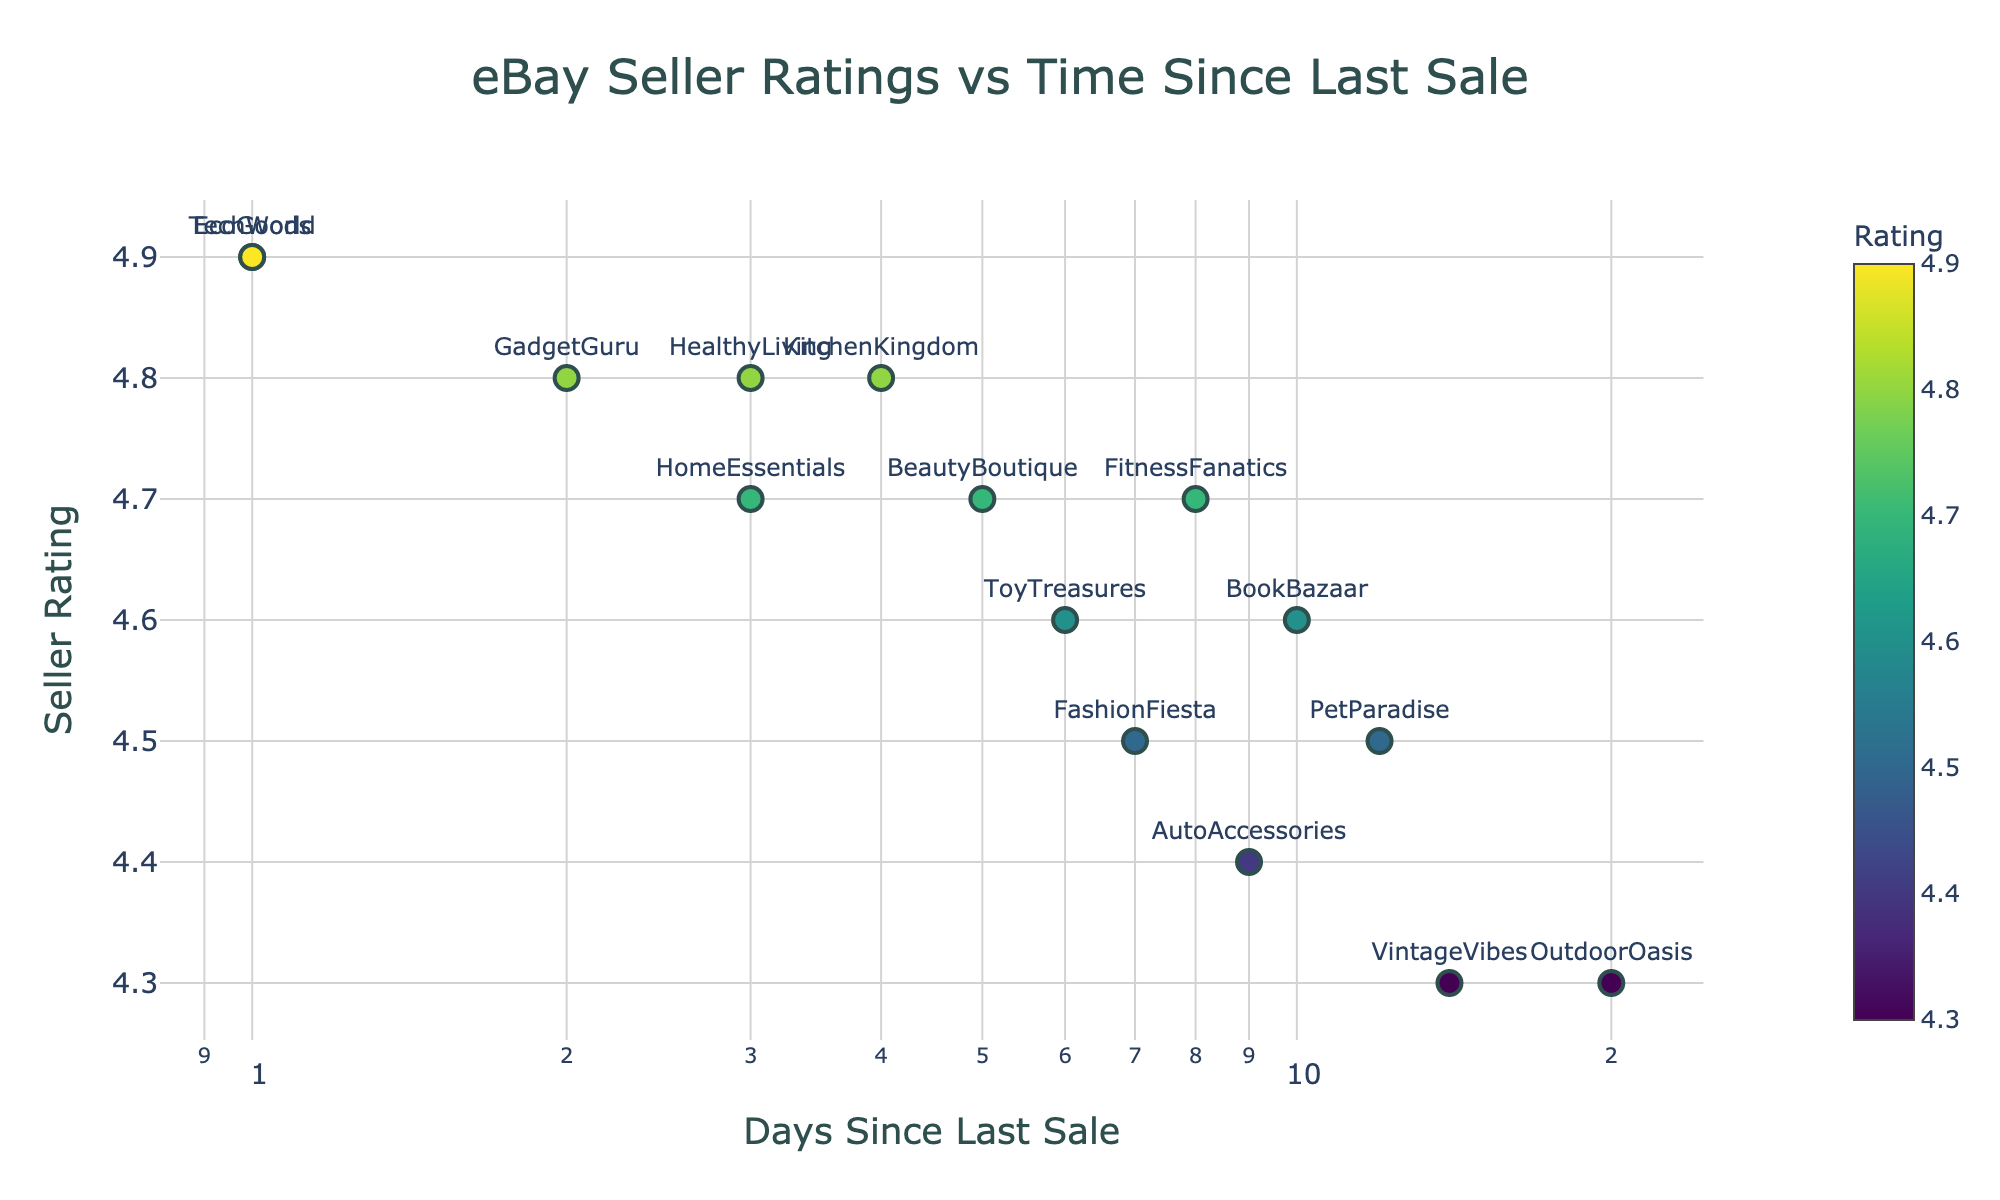How many stores are represented in this scatter plot? You can count the number of unique text labels or points on the scatter plot. From the plot, there are 15 distinct stores: TechWorld, HomeEssentials, FashionFiesta, GadgetGuru, BookBazaar, VintageVibes, EcoGoods, PetParadise, BeautyBoutique, OutdoorOasis, KitchenKingdom, ToyTreasures, AutoAccessories, FitnessFanatics, HealthyLiving.
Answer: 15 What is the rating of the store with the most recent sale? The store with the most recent sale is the one with the lowest "Days Since Last Sale" value. In this case, both "TechWorld" and "EcoGoods" have a "Days Since Last Sale" value of 1. Both of these stores have a rating of 4.9.
Answer: 4.9 Which store has the highest rating after more than 10 days since its last sale? To determine this, look for the store with the highest rating among those with a "Days Since Last Sale" value greater than 10. "BookBazaar" has a rating of 4.6 with 10 days since last sale, and "PetParadise" has a rating of 4.5 with 12 days since last sale. "VintageVibes" has a rating of 4.3 with 14 days since last sale. The highest rating is 4.6 from "BookBazaar".
Answer: BookBazaar What is the comparison between the ratings of "TechWorld" and "HomeEssentials"? First, locate both "TechWorld" and "HomeEssentials" on the scatter plot. "TechWorld" has a rating of 4.9 and "HomeEssentials" has a rating of 4.7. Therefore, "TechWorld" has a higher rating than "HomeEssentials".
Answer: TechWorld has a higher rating How many stores have a rating of 4.8? Identify the data points with a Rating value of 4.8. The stores with this rating are "GadgetGuru", "KitchenKingdom", and "HealthyLiving". Thus, there are 3 stores with this rating.
Answer: 3 What is the median rating of all stores? List all the ratings in ascending order: 4.3, 4.3, 4.4, 4.5, 4.5, 4.5, 4.6, 4.6, 4.7, 4.7, 4.7, 4.8, 4.8, 4.8, 4.9, 4.9. Since there are 15 ratings, the median value will be the 8th value in this sorted list. So, the median rating is 4.6.
Answer: 4.6 Which store has the longest time since its last sale? What is its rating? The store with the longest time since its last sale is the one with the largest x-axis value. From the plot, "OutdoorOasis" has the highest "Days Since Last Sale" value of 20. Its rating is 4.3.
Answer: OutdoorOasis, 4.3 